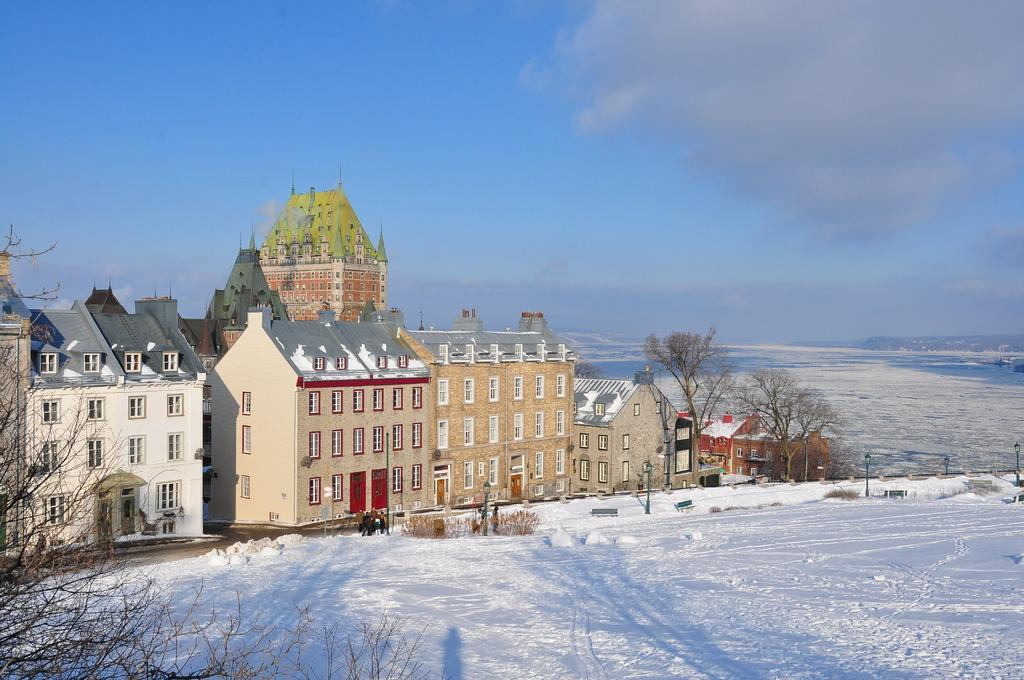What type of structures are visible in the image? There are buildings with windows in the image. What other natural elements can be seen in the image? There are trees in the image. What is the condition of the ground in the image? There is snow on the ground in the image. What is visible in the background of the image? The sky is visible in the background of the image. What is the weather like in the image? The presence of clouds in the sky suggests that it might be overcast or cloudy. Where is the drawer located in the image? There is no drawer present in the image. What type of produce can be seen growing in the image? There is no produce visible in the image. 